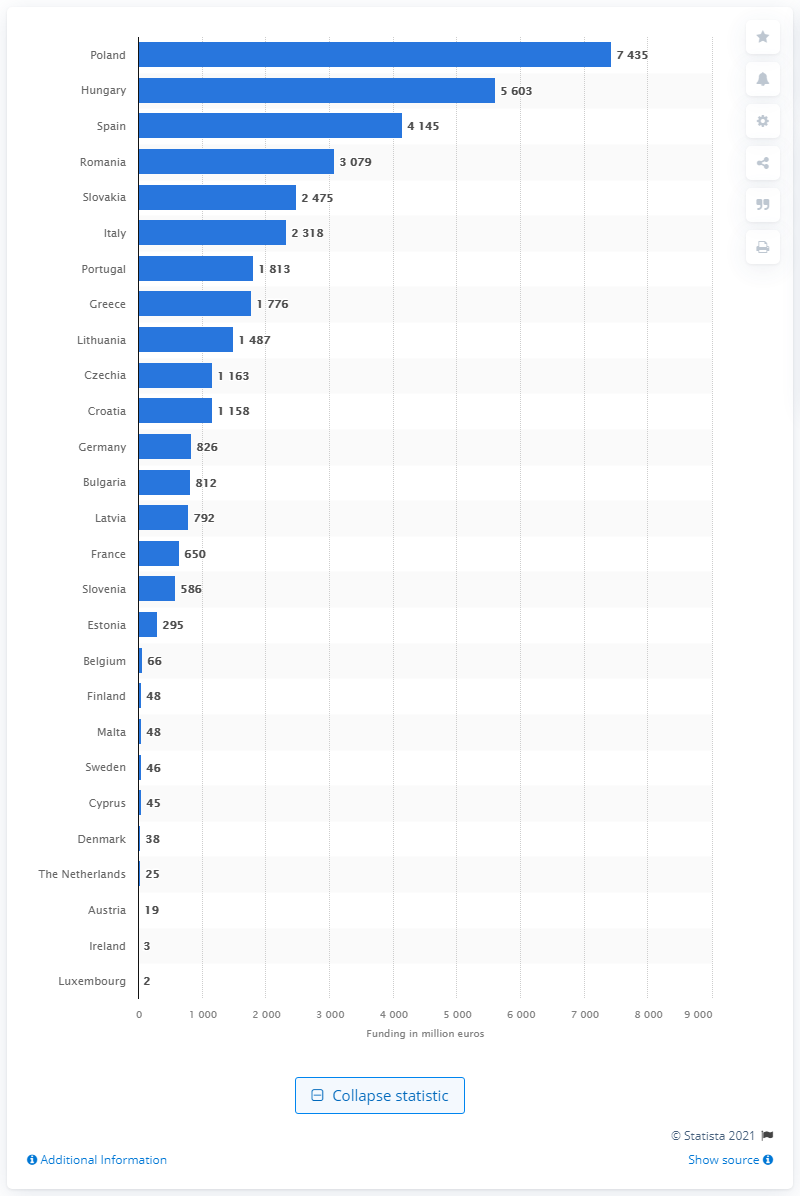Give some essential details in this illustration. According to estimates, Poland was projected to receive a total of 7,435 in 2020. 